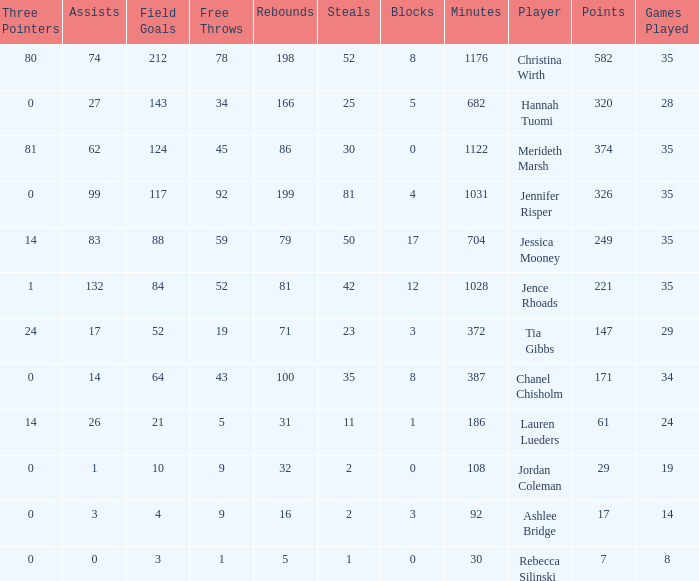What is the lowest number of games played by the player with 50 steals? 35.0. 